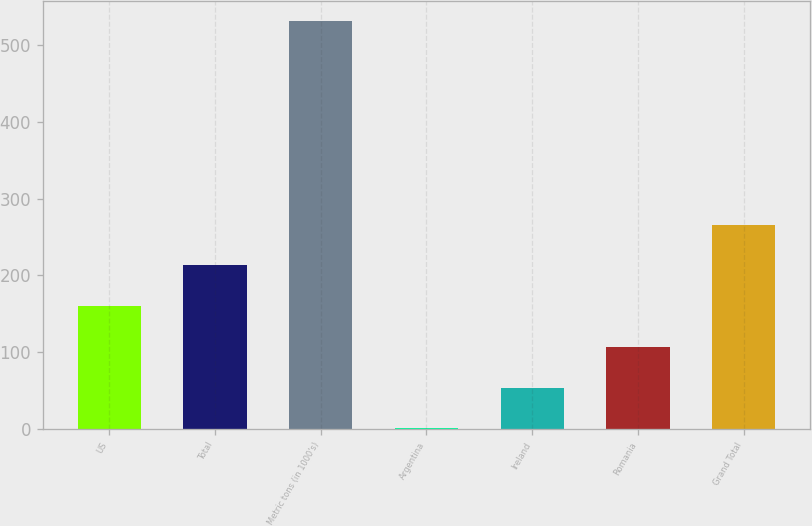Convert chart. <chart><loc_0><loc_0><loc_500><loc_500><bar_chart><fcel>US<fcel>Total<fcel>Metric tons (in 1000's)<fcel>Argentina<fcel>Ireland<fcel>Romania<fcel>Grand Total<nl><fcel>160<fcel>213<fcel>531<fcel>1<fcel>54<fcel>107<fcel>266<nl></chart> 